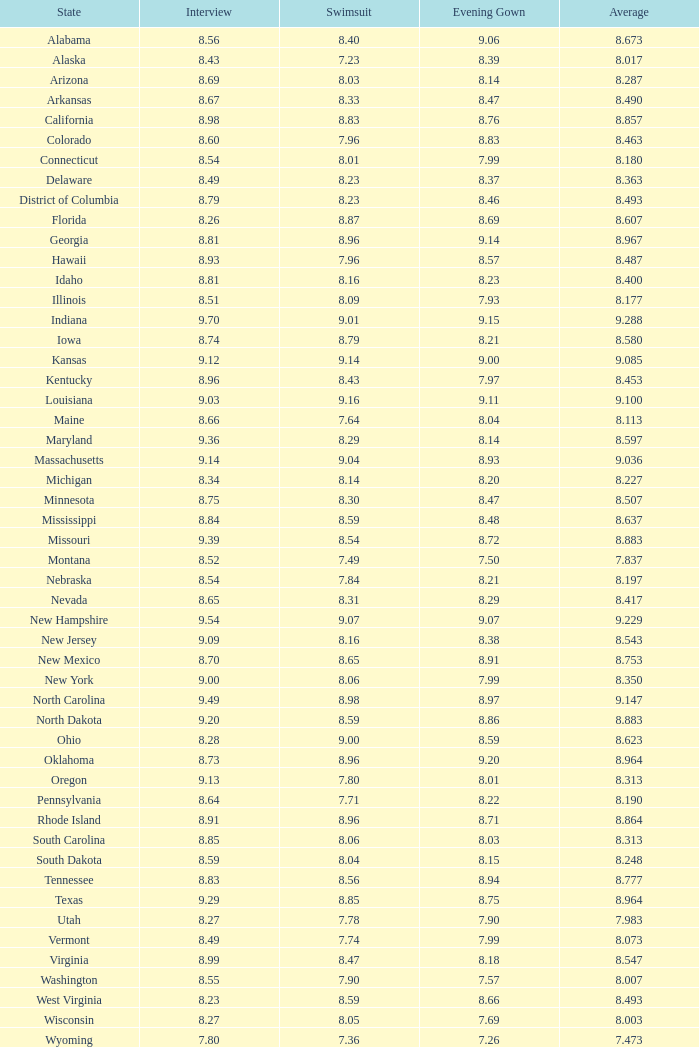Tell me the sum of interview for evening gown more than 8.37 and average of 8.363 None. 